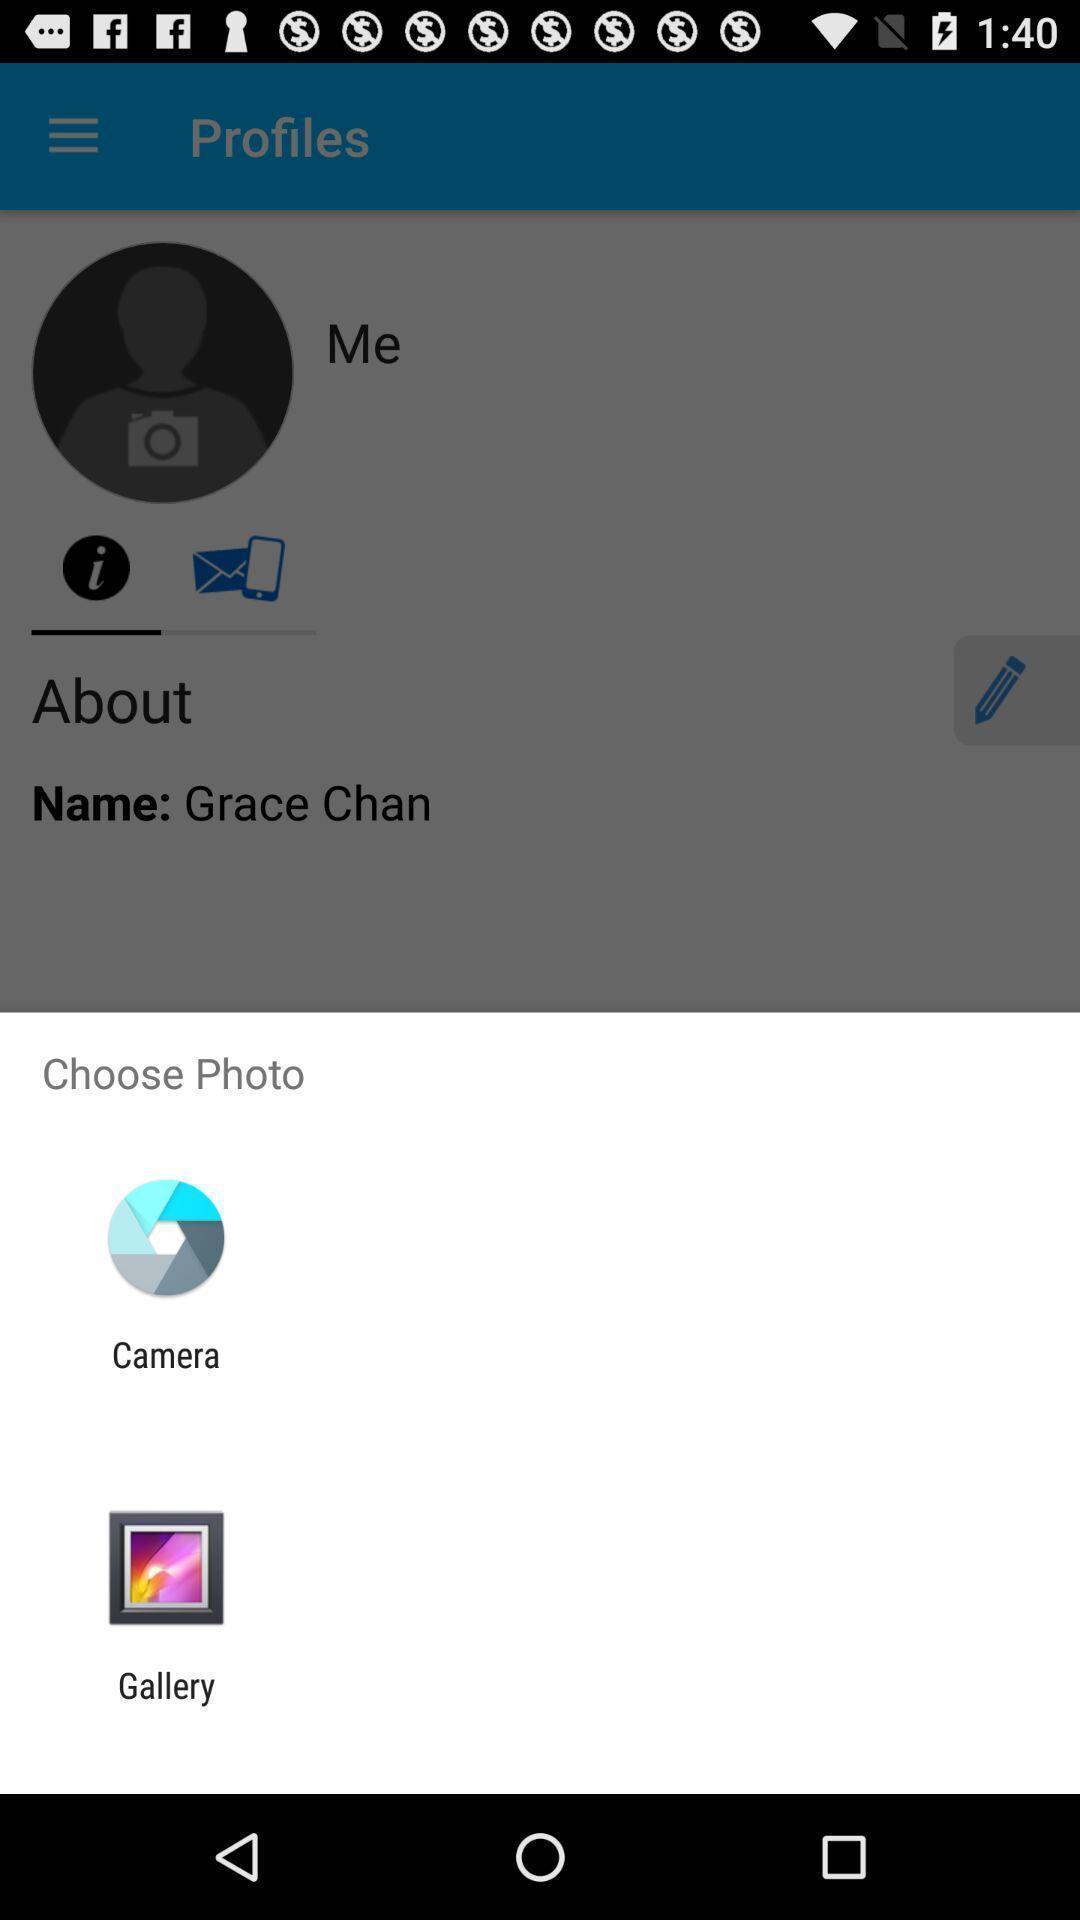What details can you identify in this image? Pop up shows to choose the photo to add profile. 